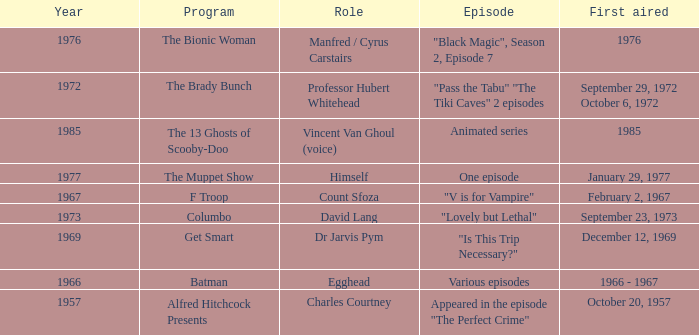What episode was first aired in 1976? "Black Magic", Season 2, Episode 7. 